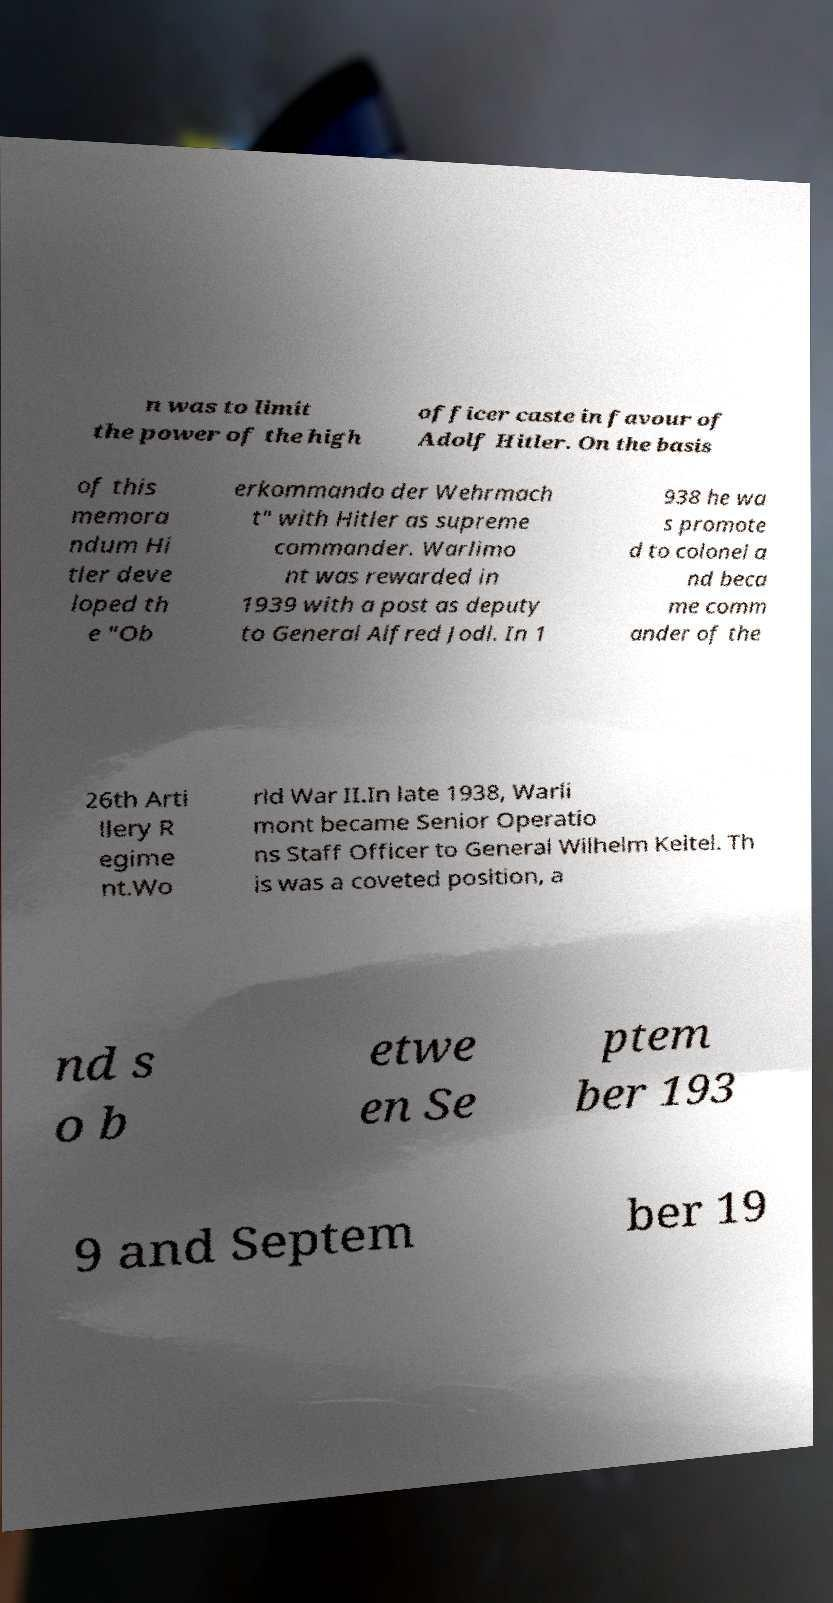Please identify and transcribe the text found in this image. n was to limit the power of the high officer caste in favour of Adolf Hitler. On the basis of this memora ndum Hi tler deve loped th e "Ob erkommando der Wehrmach t" with Hitler as supreme commander. Warlimo nt was rewarded in 1939 with a post as deputy to General Alfred Jodl. In 1 938 he wa s promote d to colonel a nd beca me comm ander of the 26th Arti llery R egime nt.Wo rld War II.In late 1938, Warli mont became Senior Operatio ns Staff Officer to General Wilhelm Keitel. Th is was a coveted position, a nd s o b etwe en Se ptem ber 193 9 and Septem ber 19 